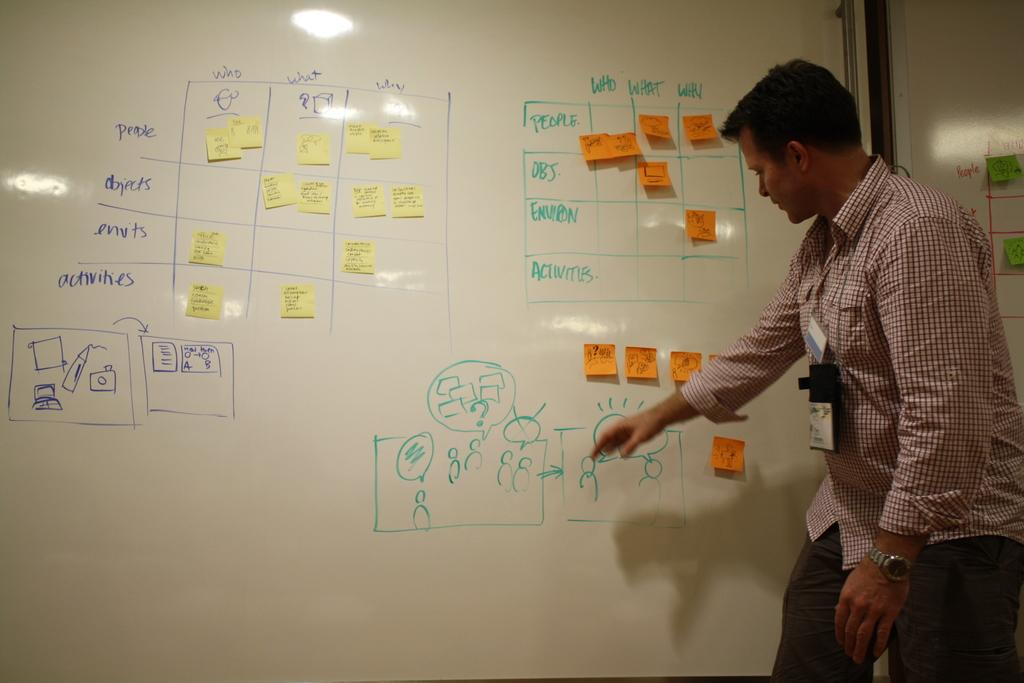<image>
Describe the image concisely. A man writes on a whiteboard with the word people on it. 